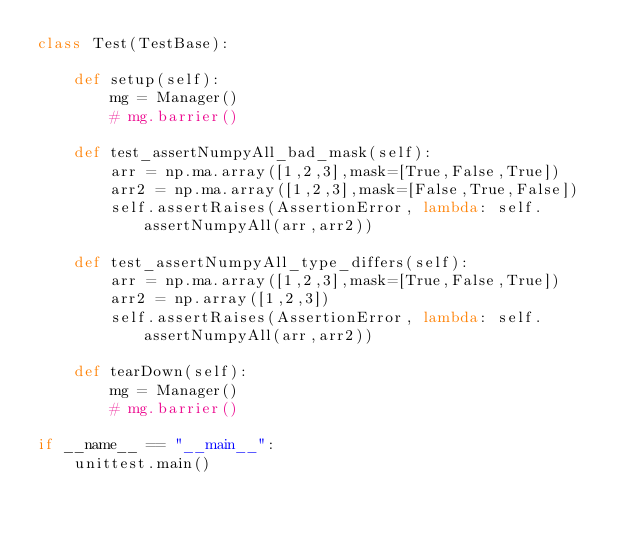Convert code to text. <code><loc_0><loc_0><loc_500><loc_500><_Python_>class Test(TestBase):

    def setup(self):
        mg = Manager()
        # mg.barrier()

    def test_assertNumpyAll_bad_mask(self):
        arr = np.ma.array([1,2,3],mask=[True,False,True])
        arr2 = np.ma.array([1,2,3],mask=[False,True,False])
        self.assertRaises(AssertionError, lambda: self.assertNumpyAll(arr,arr2))
            
    def test_assertNumpyAll_type_differs(self):
        arr = np.ma.array([1,2,3],mask=[True,False,True])
        arr2 = np.array([1,2,3])
        self.assertRaises(AssertionError, lambda: self.assertNumpyAll(arr,arr2))

    def tearDown(self):
        mg = Manager()
        # mg.barrier()

if __name__ == "__main__":
    unittest.main()</code> 